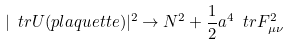Convert formula to latex. <formula><loc_0><loc_0><loc_500><loc_500>| \ t r U ( p l a q u e t t e ) | ^ { 2 } \rightarrow N ^ { 2 } + \frac { 1 } { 2 } a ^ { 4 } \ t r F _ { \mu \nu } ^ { 2 }</formula> 